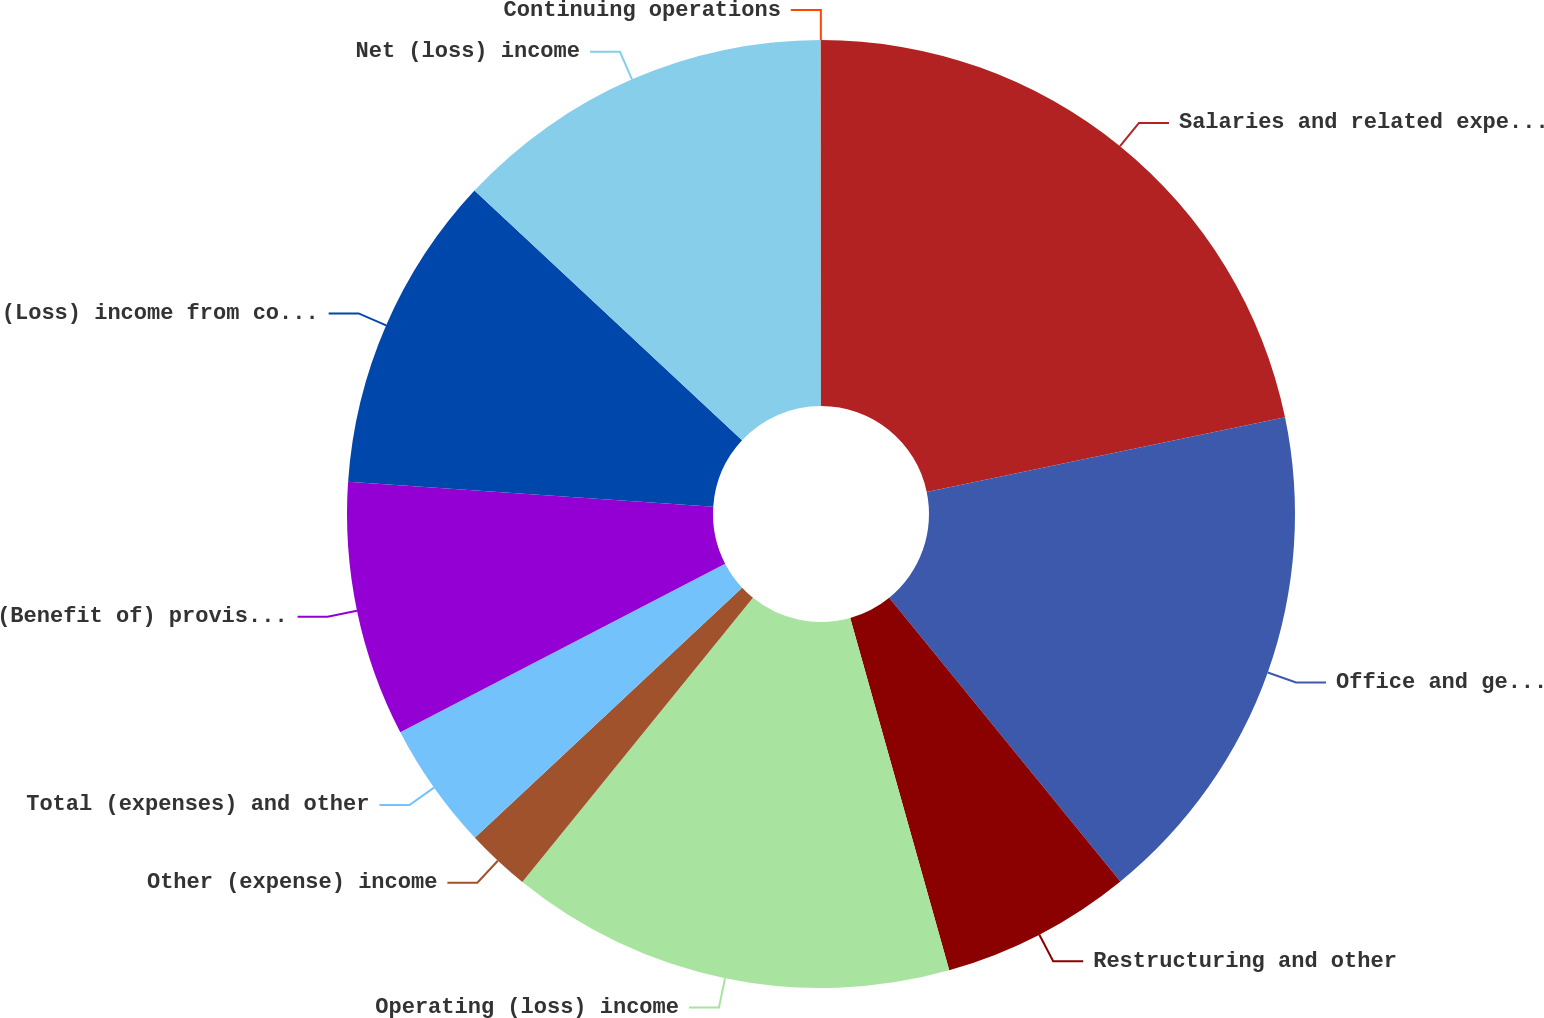Convert chart. <chart><loc_0><loc_0><loc_500><loc_500><pie_chart><fcel>Salaries and related expenses<fcel>Office and general expenses<fcel>Restructuring and other<fcel>Operating (loss) income<fcel>Other (expense) income<fcel>Total (expenses) and other<fcel>(Benefit of) provision for<fcel>(Loss) income from continuing<fcel>Net (loss) income<fcel>Continuing operations<nl><fcel>21.73%<fcel>17.39%<fcel>6.52%<fcel>15.21%<fcel>2.18%<fcel>4.35%<fcel>8.7%<fcel>10.87%<fcel>13.04%<fcel>0.01%<nl></chart> 